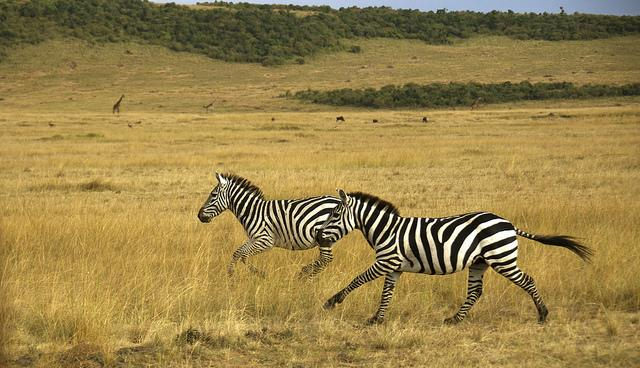How many zebras are running across the savannah plain?

Choices:
A) three
B) one
C) two
D) five two 